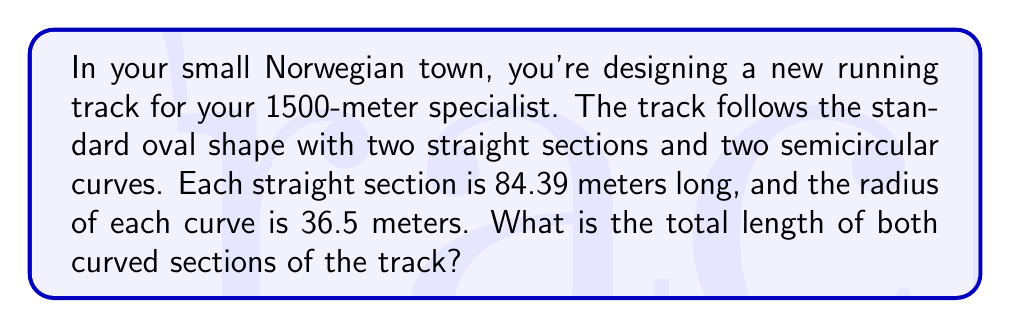Show me your answer to this math problem. Let's approach this step-by-step using the arc length formula:

1) The arc length formula for a semicircle is:

   $$s = \theta r$$

   Where $s$ is the arc length, $\theta$ is the angle in radians, and $r$ is the radius.

2) For a semicircle, the angle $\theta$ is always $\pi$ radians (180°).

3) We're given that the radius $r$ is 36.5 meters.

4) Let's substitute these values into the formula:

   $$s = \pi \cdot 36.5$$

5) Calculate:
   
   $$s = 3.14159... \cdot 36.5 \approx 114.66$$

6) This gives us the length of one semicircular curve. Since there are two curves, we need to double this:

   $$\text{Total curve length} = 2 \cdot 114.66 \approx 229.32$$

Therefore, the total length of both curved sections is approximately 229.32 meters.

[asy]
unitsize(2mm);
path track = (0,0)--(84.39,0)::(-36.5,36.5)--(0,73)--(84.39,73)::(120.89,36.5)--cycle;
draw(track);
label("84.39m", (42,0), S);
label("84.39m", (42,73), N);
label("r=36.5m", (120.89,36.5), E);
[/asy]
Answer: The total length of both curved sections of the track is approximately 229.32 meters. 